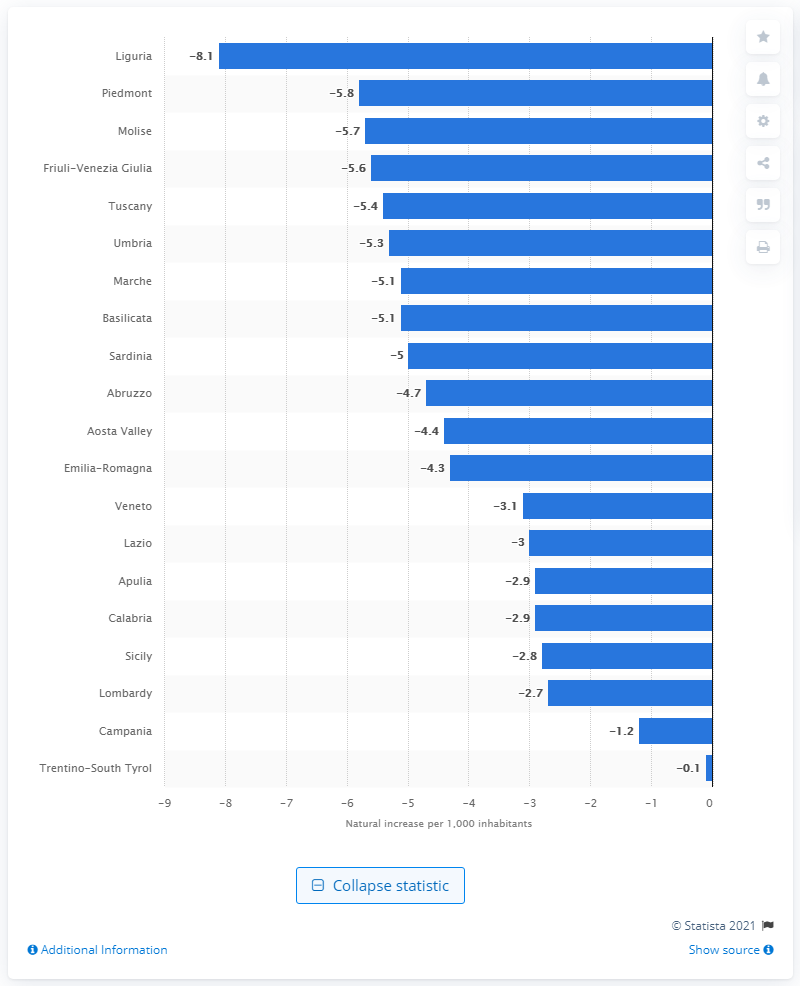List a handful of essential elements in this visual. In 2019, the region of Trentino-South Tyrol in Italy experienced the mildest decrease in population among all regions in the country. 